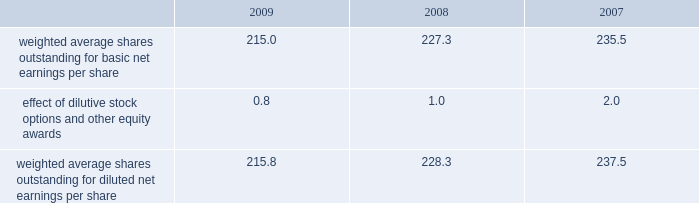14 .
Capital stock and earnings per share we are authorized to issue 250 million shares of preferred stock , none of which were issued or outstanding as of december 31 , 2009 .
The numerator for both basic and diluted earnings per share is net earnings available to common stockholders .
The denominator for basic earnings per share is the weighted average number of common shares outstanding during the period .
The denominator for diluted earnings per share is weighted average shares outstanding adjusted for the effect of dilutive stock options and other equity awards .
The following is a reconciliation of weighted average shares for the basic and diluted share computations for the years ending december 31 ( in millions ) : .
Weighted average shares outstanding for basic net earnings per share 215.0 227.3 235.5 effect of dilutive stock options and other equity awards 0.8 1.0 2.0 weighted average shares outstanding for diluted net earnings per share 215.8 228.3 237.5 for the year ended december 31 , 2009 , an average of 14.3 million options to purchase shares of common stock were not included in the computation of diluted earnings per share as the exercise prices of these options were greater than the average market price of the common stock .
For the years ended december 31 , 2008 and 2007 , an average of 11.2 million and 3.1 million options , respectively , were not included .
During 2009 , we repurchased approximately 19.8 million shares of our common stock at an average price of $ 46.56 per share for a total cash outlay of $ 923.7 million , including commissions .
In april 2008 , we announced that our board of directors authorized a $ 1.25 billion share repurchase program which was originally set to expire on december 31 , 2009 .
In september 2009 , the board of directors extended this program to december 31 , 2010 .
Approximately $ 211.1 million remains authorized for future repurchases under this plan .
15 .
Segment data we design , develop , manufacture and market orthopaedic reconstructive implants , dental implants , spinal implants , trauma products and related surgical products which include surgical supplies and instruments designed to aid in surgical procedures and post-operation rehabilitation .
We also provide other healthcare-related services .
Revenue related to these services currently represents less than 1 percent of our total net sales .
We manage operations through three major geographic segments 2013 the americas , which is comprised principally of the united states and includes other north , central and south american markets ; europe , which is comprised principally of europe and includes the middle east and africa ; and asia pacific , which is comprised primarily of japan and includes other asian and pacific markets .
This structure is the basis for our reportable segment information discussed below .
Management evaluates reportable segment performance based upon segment operating profit exclusive of operating expenses pertaining to global operations and corporate expenses , share-based compensation expense , settlement , certain claims , acquisition , integration , realignment and other expenses , net curtailment and settlement , inventory step-up , in-process research and development write-offs and intangible asset amortization expense .
Global operations include research , development engineering , medical education , brand management , corporate legal , finance , and human resource functions and u.s .
And puerto rico-based manufacturing operations and logistics .
Intercompany transactions have been eliminated from segment operating profit .
Management reviews accounts receivable , inventory , property , plant and equipment , goodwill and intangible assets by reportable segment exclusive of u.s .
And puerto rico-based manufacturing operations and logistics and corporate assets .
Z i m m e r h o l d i n g s , i n c .
2 0 0 9 f o r m 1 0 - k a n n u a l r e p o r t notes to consolidated financial statements ( continued ) %%transmsg*** transmitting job : c55340 pcn : 060000000 ***%%pcmsg|60 |00007|yes|no|02/24/2010 01:32|0|0|page is valid , no graphics -- color : d| .
What is the percent change in weighted average shares outstanding for basic net earnings per share between 2008 and 2009? 
Rationale: i know these questions are very similar but there is not much else that can be gathered from the sample that has not already been stated
Computations: ((215.0 - 227.3) / 227.3)
Answer: -0.05411. 